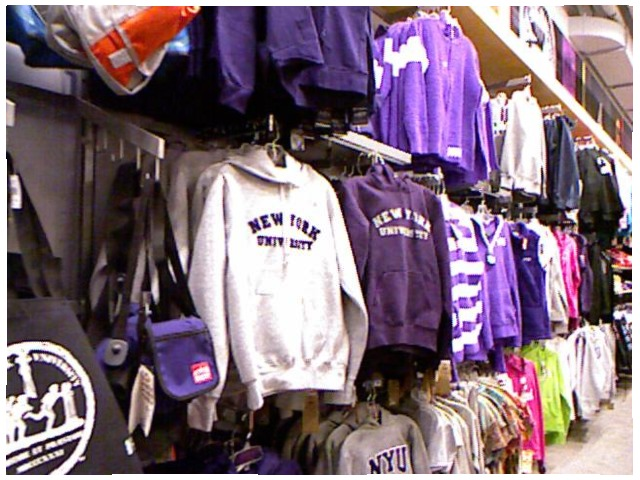<image>
Is the purse in front of the sweater? No. The purse is not in front of the sweater. The spatial positioning shows a different relationship between these objects. Where is the white dress in relation to the purple dress? Is it to the left of the purple dress? Yes. From this viewpoint, the white dress is positioned to the left side relative to the purple dress. Is the t shirt to the left of the side bag? No. The t shirt is not to the left of the side bag. From this viewpoint, they have a different horizontal relationship. Where is the sweaters in relation to the backpack? Is it next to the backpack? Yes. The sweaters is positioned adjacent to the backpack, located nearby in the same general area. Is there a jacket next to the bag? Yes. The jacket is positioned adjacent to the bag, located nearby in the same general area. 